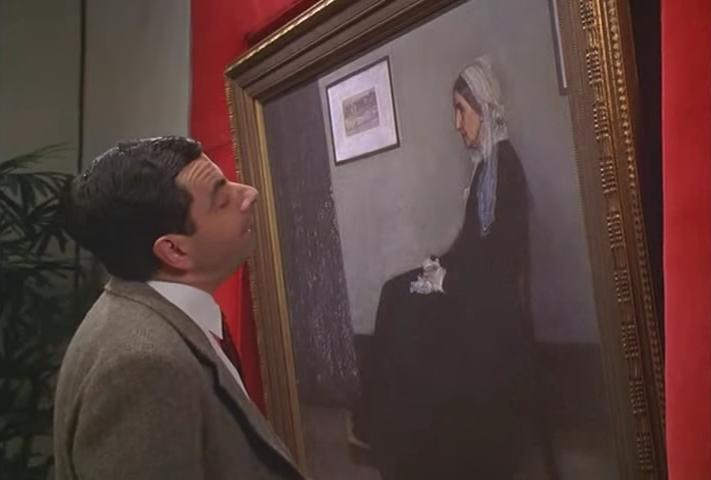Describe the setting where this interaction is taking place. The scene unfolds in an art gallery setting as suggested by the red walls which are customary in traditional galleries to provide a rich contrast to paintings. The gold frame of the portrait signifies a classic or prestigious presentation. The absence of other observers in the immediate vicinity hints at a private viewing experience. The glimpses of other frames in the background suggest the presence of more artwork, evoking the feeling of an expansive exhibition, where this unique interaction between the comedic character and classical art creates an amusing focal point. 